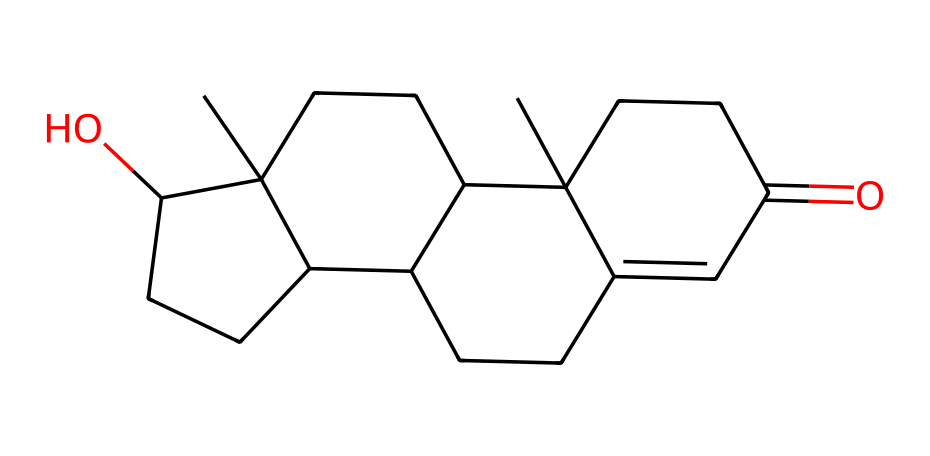What is the molecular formula of testosterone? To determine the molecular formula, we count the number of carbon (C), hydrogen (H), and oxygen (O) atoms in the SMILES representation. The structure has 19 carbon atoms, 28 hydrogen atoms, and 2 oxygen atoms, leading to the formula C19H28O2.
Answer: C19H28O2 How many rings are present in the structure of testosterone? By examining the SMILES representation, we look for indicators of ring structures, which are shown by the numbers after the atoms in the SMILES. Testosterone contains four ring structures, interconnected as indicated by the digits.
Answer: 4 What functional group is present in testosterone? In the structure, the presence of the "O" and the "=" notation suggests a carbonyl group (C=O) and the hydroxyl group (–OH) is also visible. This indicates that testosterone has both a ketone and an alcohol functional group.
Answer: ketone and alcohol What is the significance of the hydroxyl group in testosterone? The hydroxyl group (–OH) affects the solubility and reactivity of the molecule. It allows testosterone to interact in biological systems and can also influence its binding to receptors.
Answer: solubility and reactivity What is the degree of unsaturation in testosterone? The degree of unsaturation is calculated by determining the number of rings and multiple bonds. Each ring and double bond adds to the degree of unsaturation; testosterone has 4 rings and multiple double bonds, leading to a high degree of unsaturation.
Answer: high 